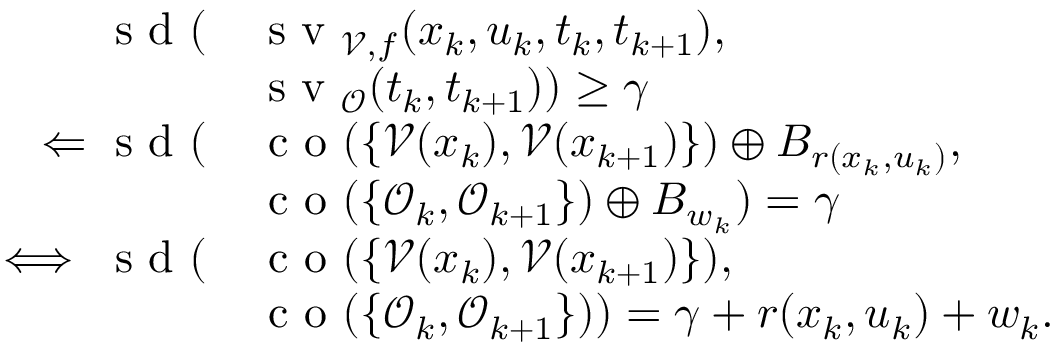<formula> <loc_0><loc_0><loc_500><loc_500>\begin{array} { r l } { s d ( } & { s v _ { \mathcal { V } , f } ( x _ { k } , u _ { k } , t _ { k } , t _ { k + 1 } ) , } \\ & { s v _ { \mathcal { O } } ( t _ { k } , t _ { k + 1 } ) ) \geq \gamma } \\ { \Leftarrow s d ( } & { c o ( \{ \mathcal { V } ( x _ { k } ) , \mathcal { V } ( x _ { k + 1 } ) \} ) \oplus B _ { r ( x _ { k } , u _ { k } ) } , } \\ & { c o ( \{ \mathcal { O } _ { k } , \mathcal { O } _ { k + 1 } \} ) \oplus B _ { w _ { k } } ) = \gamma } \\ { \iff s d ( } & { c o ( \{ \mathcal { V } ( x _ { k } ) , \mathcal { V } ( x _ { k + 1 } ) \} ) , } \\ & { c o ( \{ \mathcal { O } _ { k } , \mathcal { O } _ { k + 1 } \} ) ) = \gamma + r ( x _ { k } , u _ { k } ) + w _ { k } . } \end{array}</formula> 